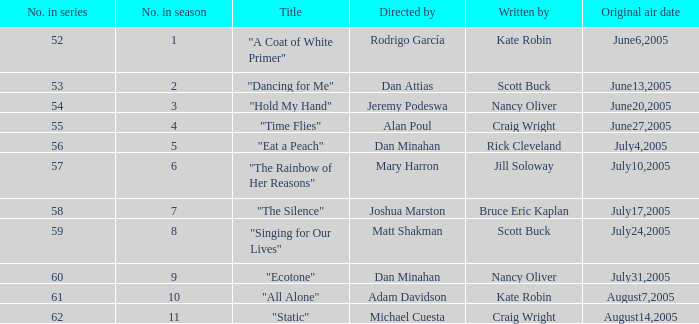What was the appellation of the episode that mary harron directed? "The Rainbow of Her Reasons". 